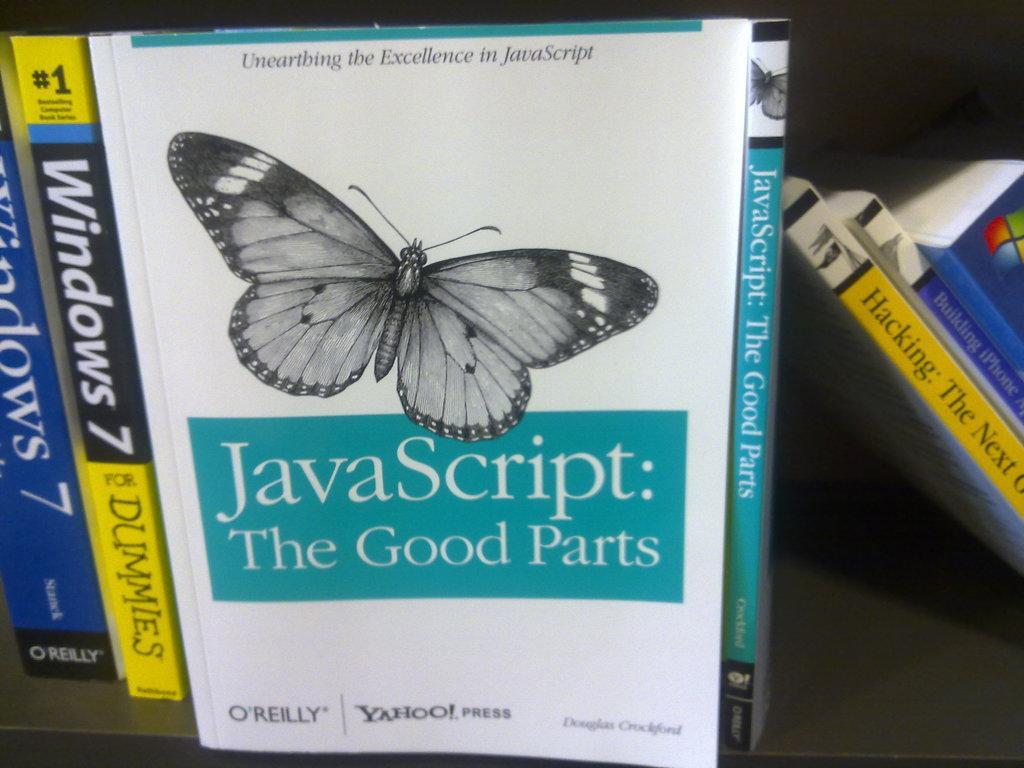Could you give a brief overview of what you see in this image? In this image we can see books arranged in the cupboard. 